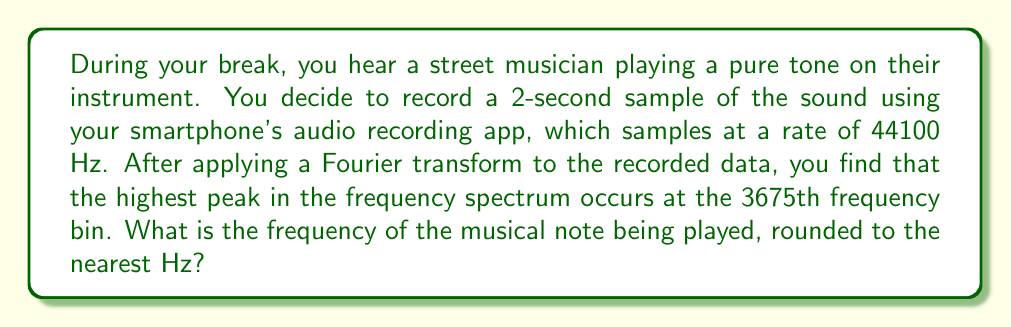Teach me how to tackle this problem. To solve this problem, we need to understand the relationship between the Fourier transform output and the actual frequency of the signal. Let's break it down step by step:

1) First, we need to calculate the frequency resolution of the Fourier transform. This is given by:

   $$ \Delta f = \frac{f_s}{N} $$

   Where $f_s$ is the sampling frequency and $N$ is the number of samples.

2) We know $f_s = 44100$ Hz, and the duration of the recording is 2 seconds. Therefore:

   $N = 44100 \text{ Hz} \times 2 \text{ s} = 88200$ samples

3) Now we can calculate $\Delta f$:

   $$ \Delta f = \frac{44100 \text{ Hz}}{88200} = 0.5 \text{ Hz} $$

4) The frequency of the kth bin in the Fourier transform is given by:

   $$ f_k = k \times \Delta f $$

   Where $k$ is the bin number.

5) We're told that the highest peak occurs at the 3675th bin. Therefore:

   $$ f = 3675 \times 0.5 \text{ Hz} = 1837.5 \text{ Hz} $$

6) Rounding to the nearest Hz:

   $$ f \approx 1838 \text{ Hz} $$

Thus, the frequency of the musical note being played is approximately 1838 Hz.
Answer: 1838 Hz 